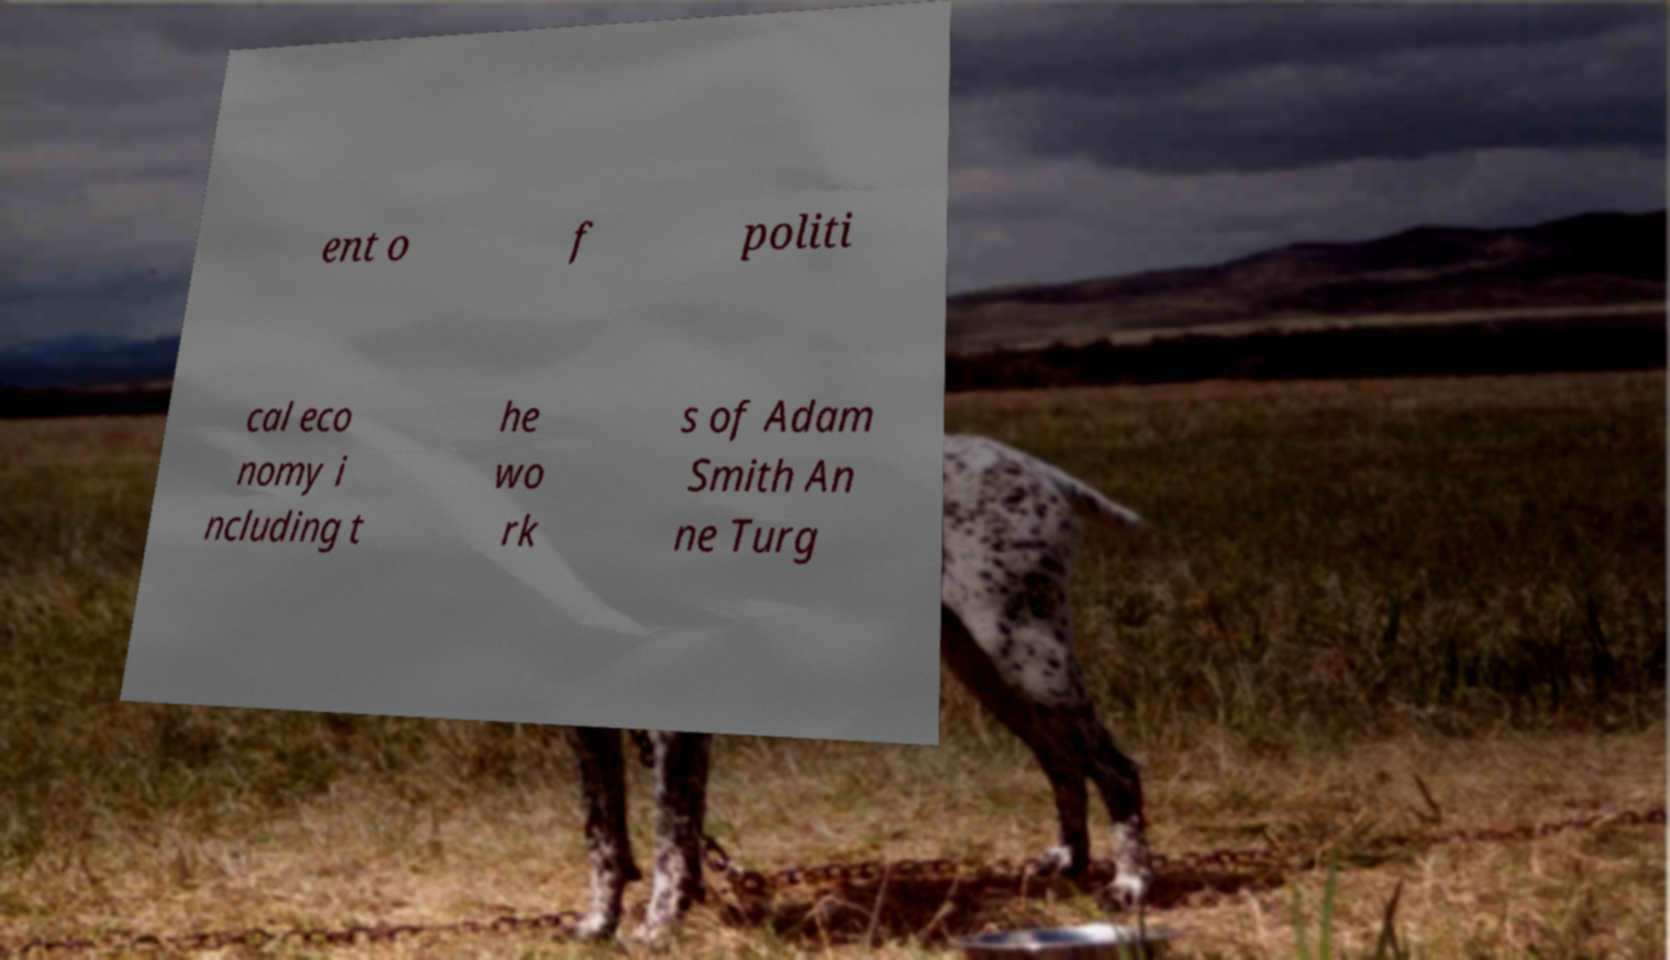Please identify and transcribe the text found in this image. ent o f politi cal eco nomy i ncluding t he wo rk s of Adam Smith An ne Turg 